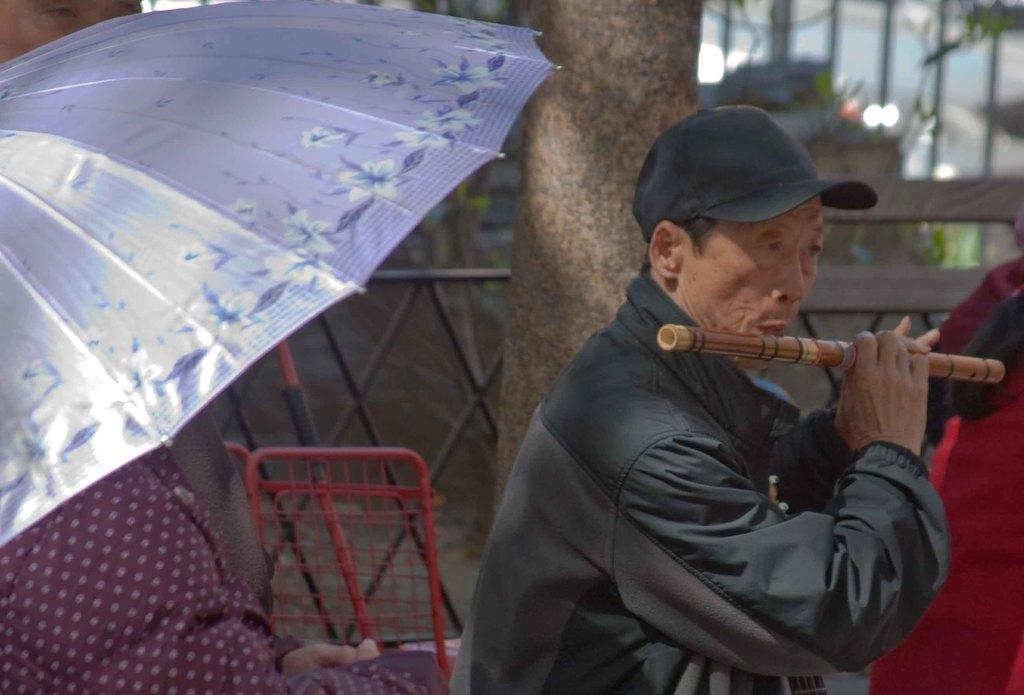What is the man in the image doing? The man is playing the flute. Can you describe any other objects in the image? Yes, there is an umbrella in the image. What type of drum can be seen being played by the kitty in the image? There is no drum or kitty present in the image; it features a man playing the flute and an umbrella. 